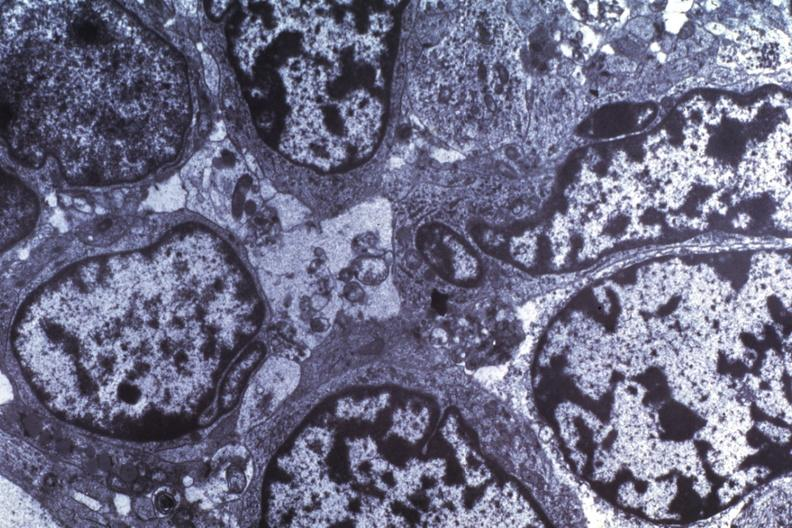what is present?
Answer the question using a single word or phrase. Medulloblastoma 